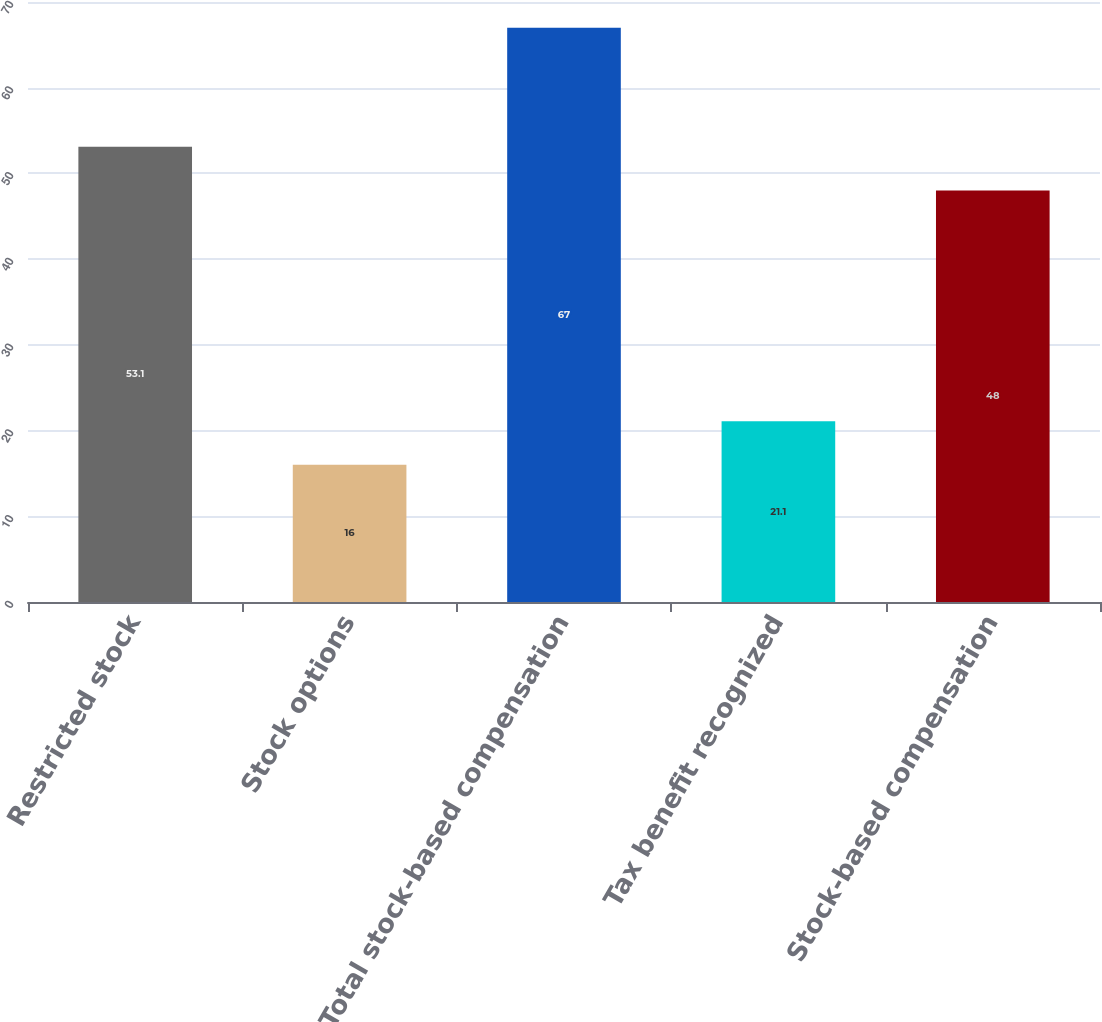<chart> <loc_0><loc_0><loc_500><loc_500><bar_chart><fcel>Restricted stock<fcel>Stock options<fcel>Total stock-based compensation<fcel>Tax benefit recognized<fcel>Stock-based compensation<nl><fcel>53.1<fcel>16<fcel>67<fcel>21.1<fcel>48<nl></chart> 